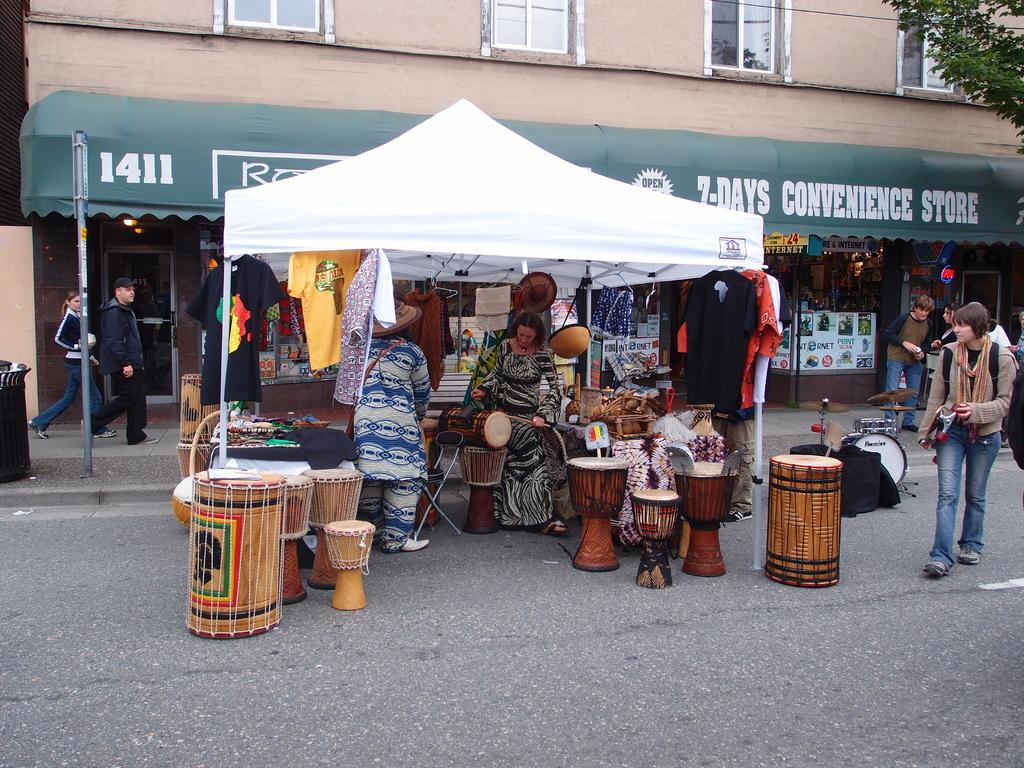What are the people in the image doing? The people in the image are standing on the road. What can be seen in the background of the image? There is a building and a white-colored tent in the background of the image. What type of process is being carried out by the frogs in the image? There are no frogs present in the image, so no such process can be observed. 